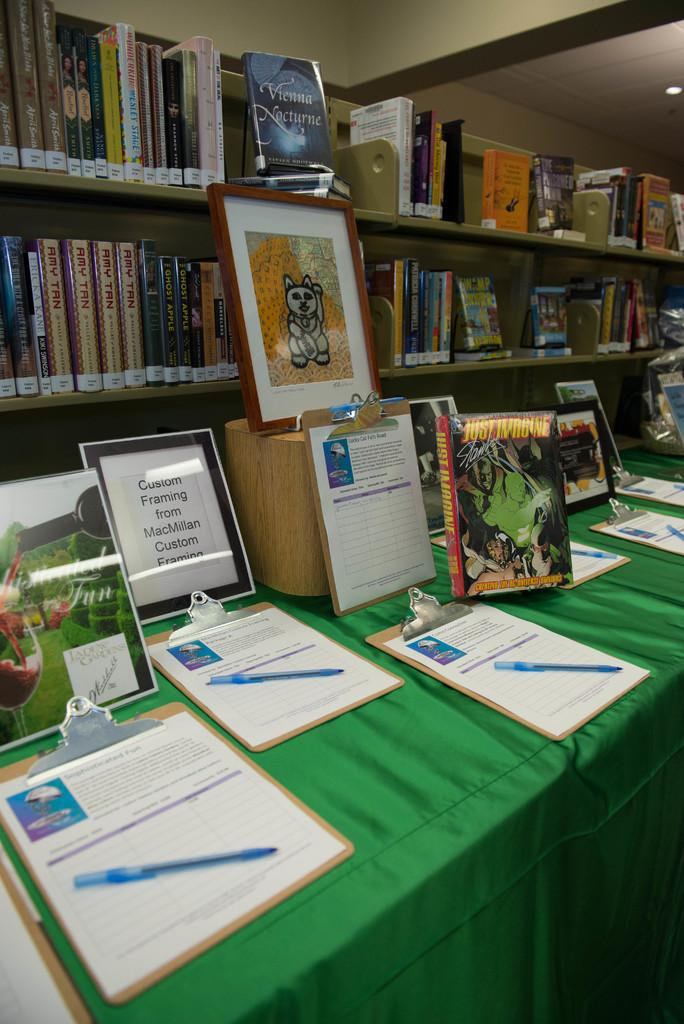<image>
Relay a brief, clear account of the picture shown. a table in front of bookshelves with a framed paper on it that says 'custom framing from macmillan custom framing' 